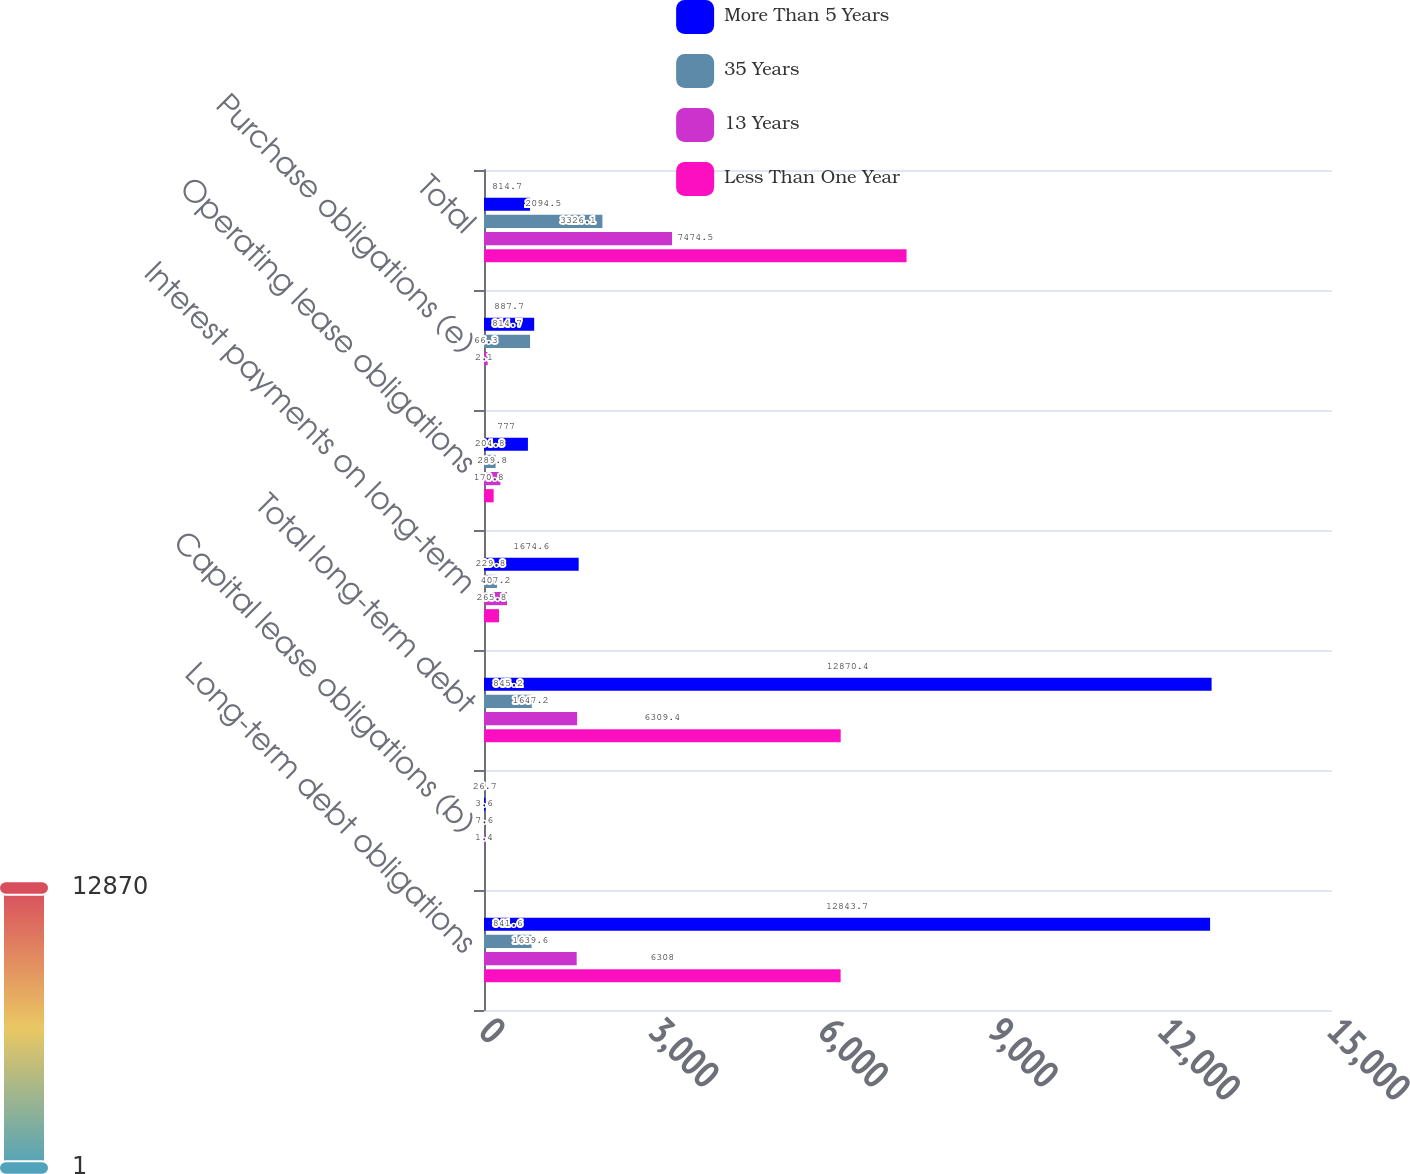Convert chart. <chart><loc_0><loc_0><loc_500><loc_500><stacked_bar_chart><ecel><fcel>Long-term debt obligations<fcel>Capital lease obligations (b)<fcel>Total long-term debt<fcel>Interest payments on long-term<fcel>Operating lease obligations<fcel>Purchase obligations (e)<fcel>Total<nl><fcel>More Than 5 Years<fcel>12843.7<fcel>26.7<fcel>12870.4<fcel>1674.6<fcel>777<fcel>887.7<fcel>814.7<nl><fcel>35 Years<fcel>841.6<fcel>3.6<fcel>845.2<fcel>229.8<fcel>204.8<fcel>814.7<fcel>2094.5<nl><fcel>13 Years<fcel>1639.6<fcel>7.6<fcel>1647.2<fcel>407.2<fcel>289.8<fcel>66.3<fcel>3326.1<nl><fcel>Less Than One Year<fcel>6308<fcel>1.4<fcel>6309.4<fcel>265.8<fcel>170.8<fcel>2.1<fcel>7474.5<nl></chart> 